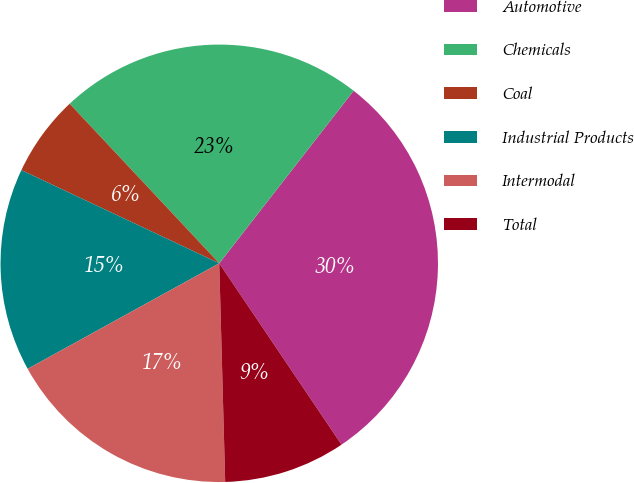Convert chart to OTSL. <chart><loc_0><loc_0><loc_500><loc_500><pie_chart><fcel>Automotive<fcel>Chemicals<fcel>Coal<fcel>Industrial Products<fcel>Intermodal<fcel>Total<nl><fcel>30.03%<fcel>22.52%<fcel>6.01%<fcel>15.02%<fcel>17.42%<fcel>9.01%<nl></chart> 